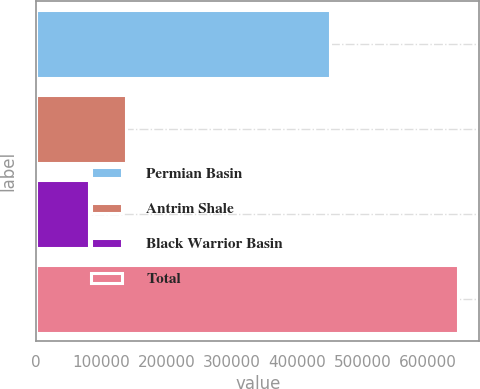<chart> <loc_0><loc_0><loc_500><loc_500><bar_chart><fcel>Permian Basin<fcel>Antrim Shale<fcel>Black Warrior Basin<fcel>Total<nl><fcel>450746<fcel>136940<fcel>80331<fcel>646422<nl></chart> 